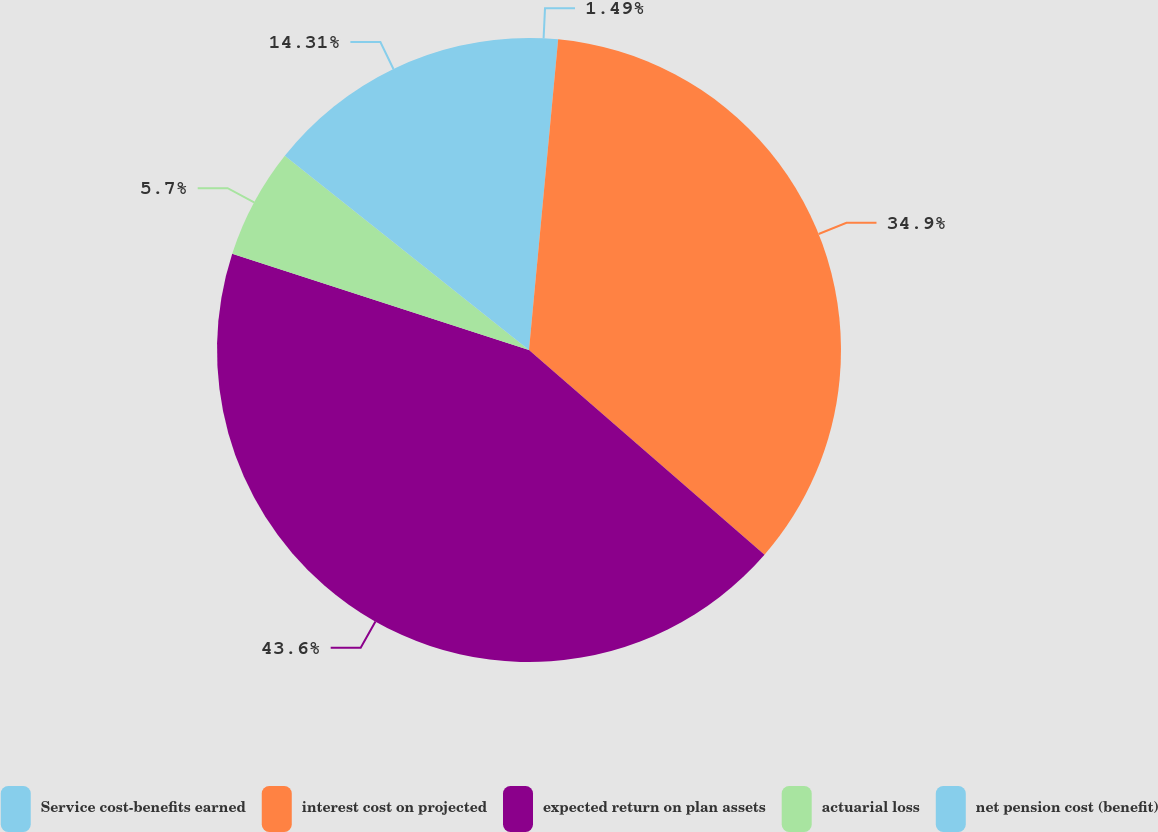Convert chart to OTSL. <chart><loc_0><loc_0><loc_500><loc_500><pie_chart><fcel>Service cost-benefits earned<fcel>interest cost on projected<fcel>expected return on plan assets<fcel>actuarial loss<fcel>net pension cost (benefit)<nl><fcel>1.49%<fcel>34.9%<fcel>43.61%<fcel>5.7%<fcel>14.31%<nl></chart> 